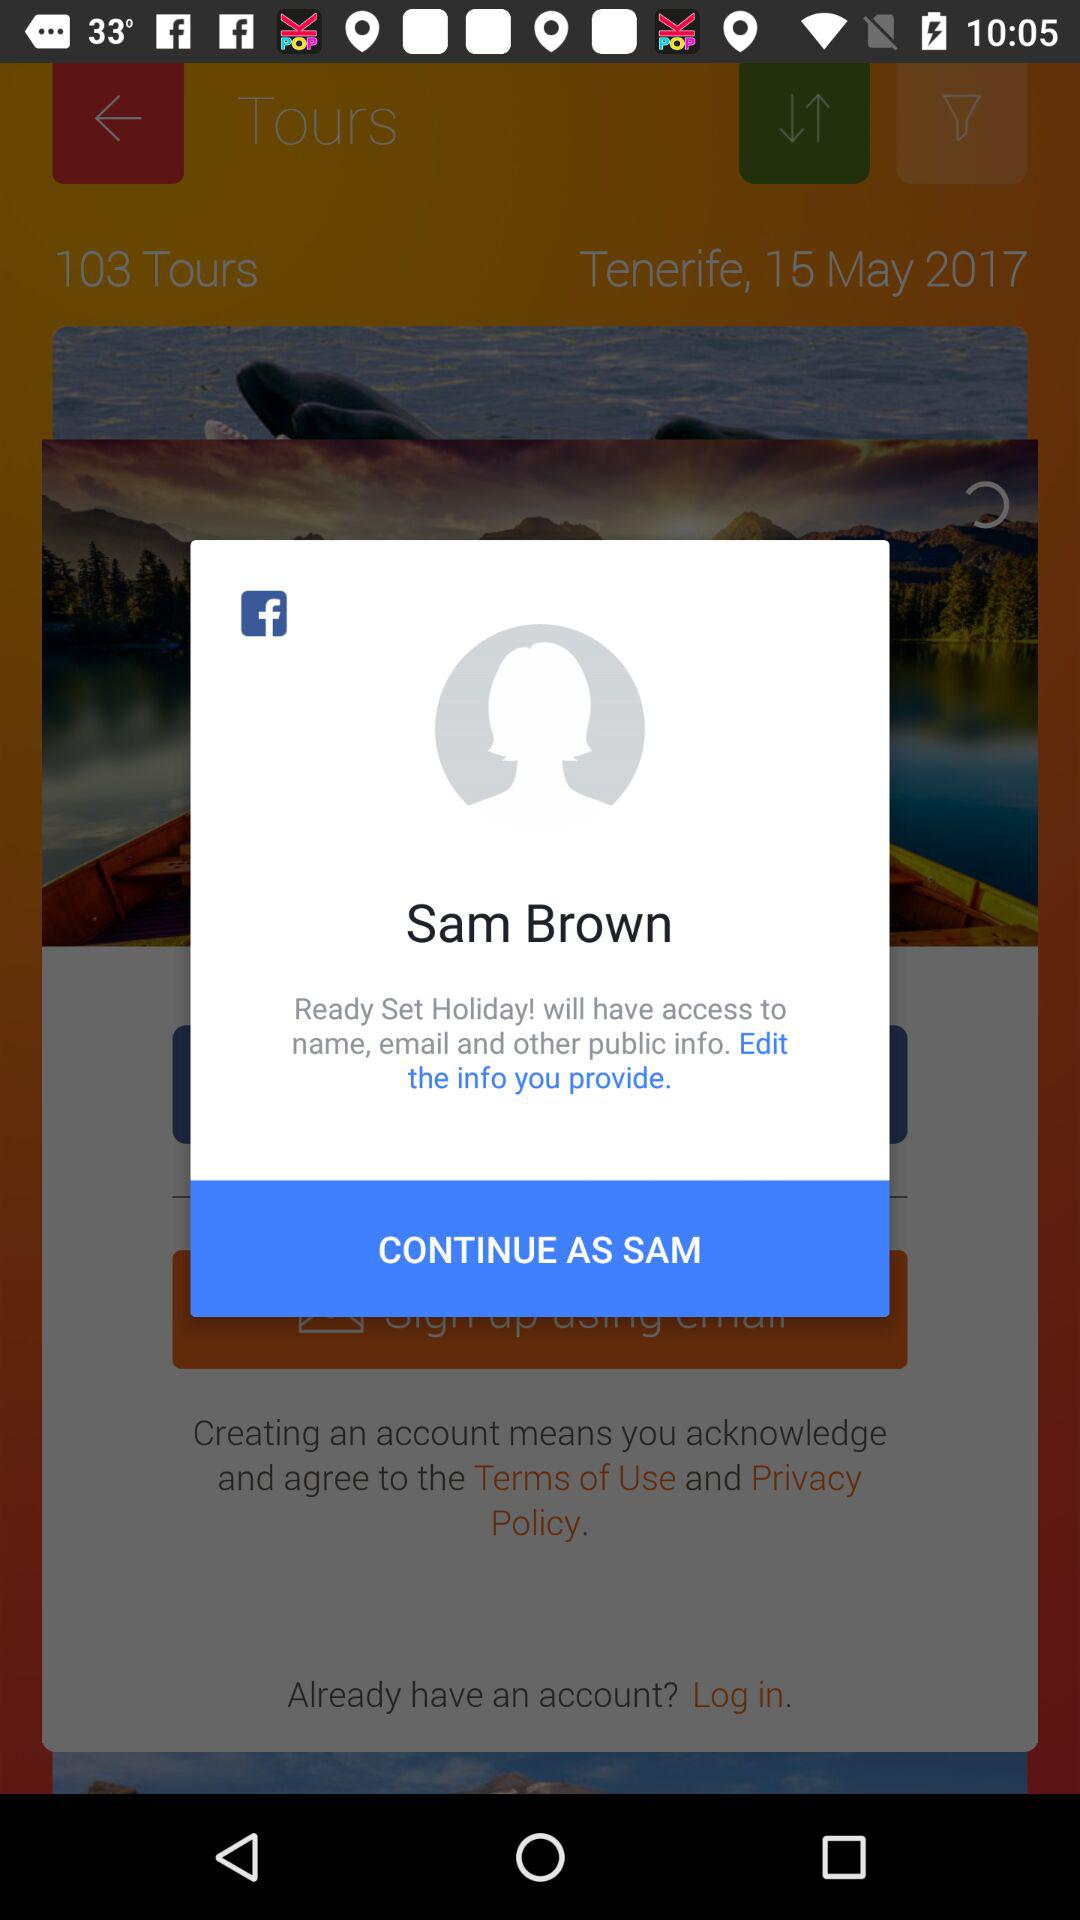What is the user name? The user name is Sam Brown. 